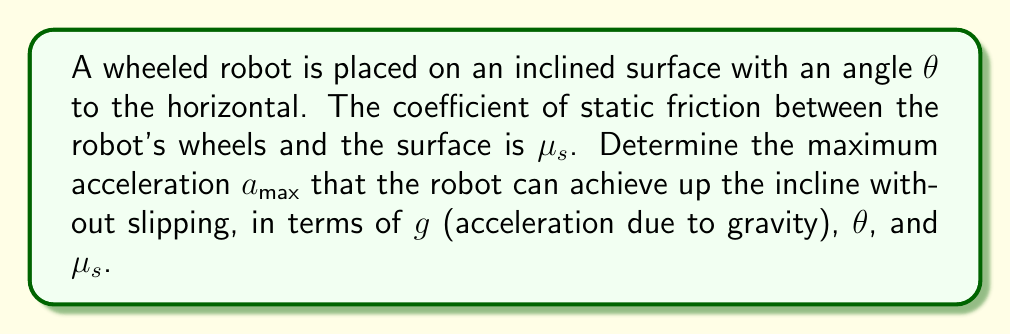Could you help me with this problem? To solve this problem, we'll follow these steps:

1) Draw a free body diagram of the robot on the incline.

2) Apply Newton's Second Law in both parallel and perpendicular directions to the incline.

3) Use the condition for maximum acceleration without slipping.

4) Solve for the maximum acceleration.

Step 1: Free body diagram
[asy]
import geometry;

size(200);
pair O=(0,0), A=(100,50), B=(100,0);
draw(O--A--B--O);
draw((-10,0)--(110,0),arrow=Arrow(TeXHead));
draw((0,-10)--(0,60),arrow=Arrow(TeXHead));

label("$\theta$", (10,5), E);
label("$mg$", (50,25), S);
label("$F_f$", (85,55), NW);
label("$N$", (105,25), E);
label("$ma$", (50,55), N);

draw((50,50)--(50,0),dashed);
draw((50,50)--(100,50),dashed);
draw((50,0)--(100,0),dashed);
[/asy]

Step 2: Apply Newton's Second Law

Parallel to the incline:
$$ma = mg\sin\theta - F_f$$

Perpendicular to the incline:
$$N = mg\cos\theta$$

Step 3: Maximum acceleration condition

The maximum friction force is given by:
$$F_f = \mu_s N = \mu_s mg\cos\theta$$

Step 4: Solve for maximum acceleration

Substitute the friction force into the parallel equation:
$$ma_{max} = mg\sin\theta - \mu_s mg\cos\theta$$

Divide both sides by $m$:
$$a_{max} = g\sin\theta - \mu_s g\cos\theta$$

Factor out $g$:
$$a_{max} = g(\sin\theta - \mu_s \cos\theta)$$

This is the maximum acceleration the robot can achieve up the incline without slipping.
Answer: $a_{max} = g(\sin\theta - \mu_s \cos\theta)$ 